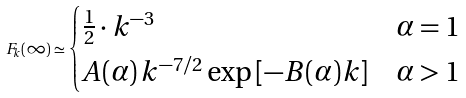Convert formula to latex. <formula><loc_0><loc_0><loc_500><loc_500>F _ { k } ( \infty ) \simeq \begin{cases} \frac { 1 } { 2 } \cdot k ^ { - 3 } & \alpha = 1 \\ A ( \alpha ) \, k ^ { - 7 / 2 } \exp \left [ - B ( \alpha ) k \right ] & \alpha > 1 \end{cases}</formula> 